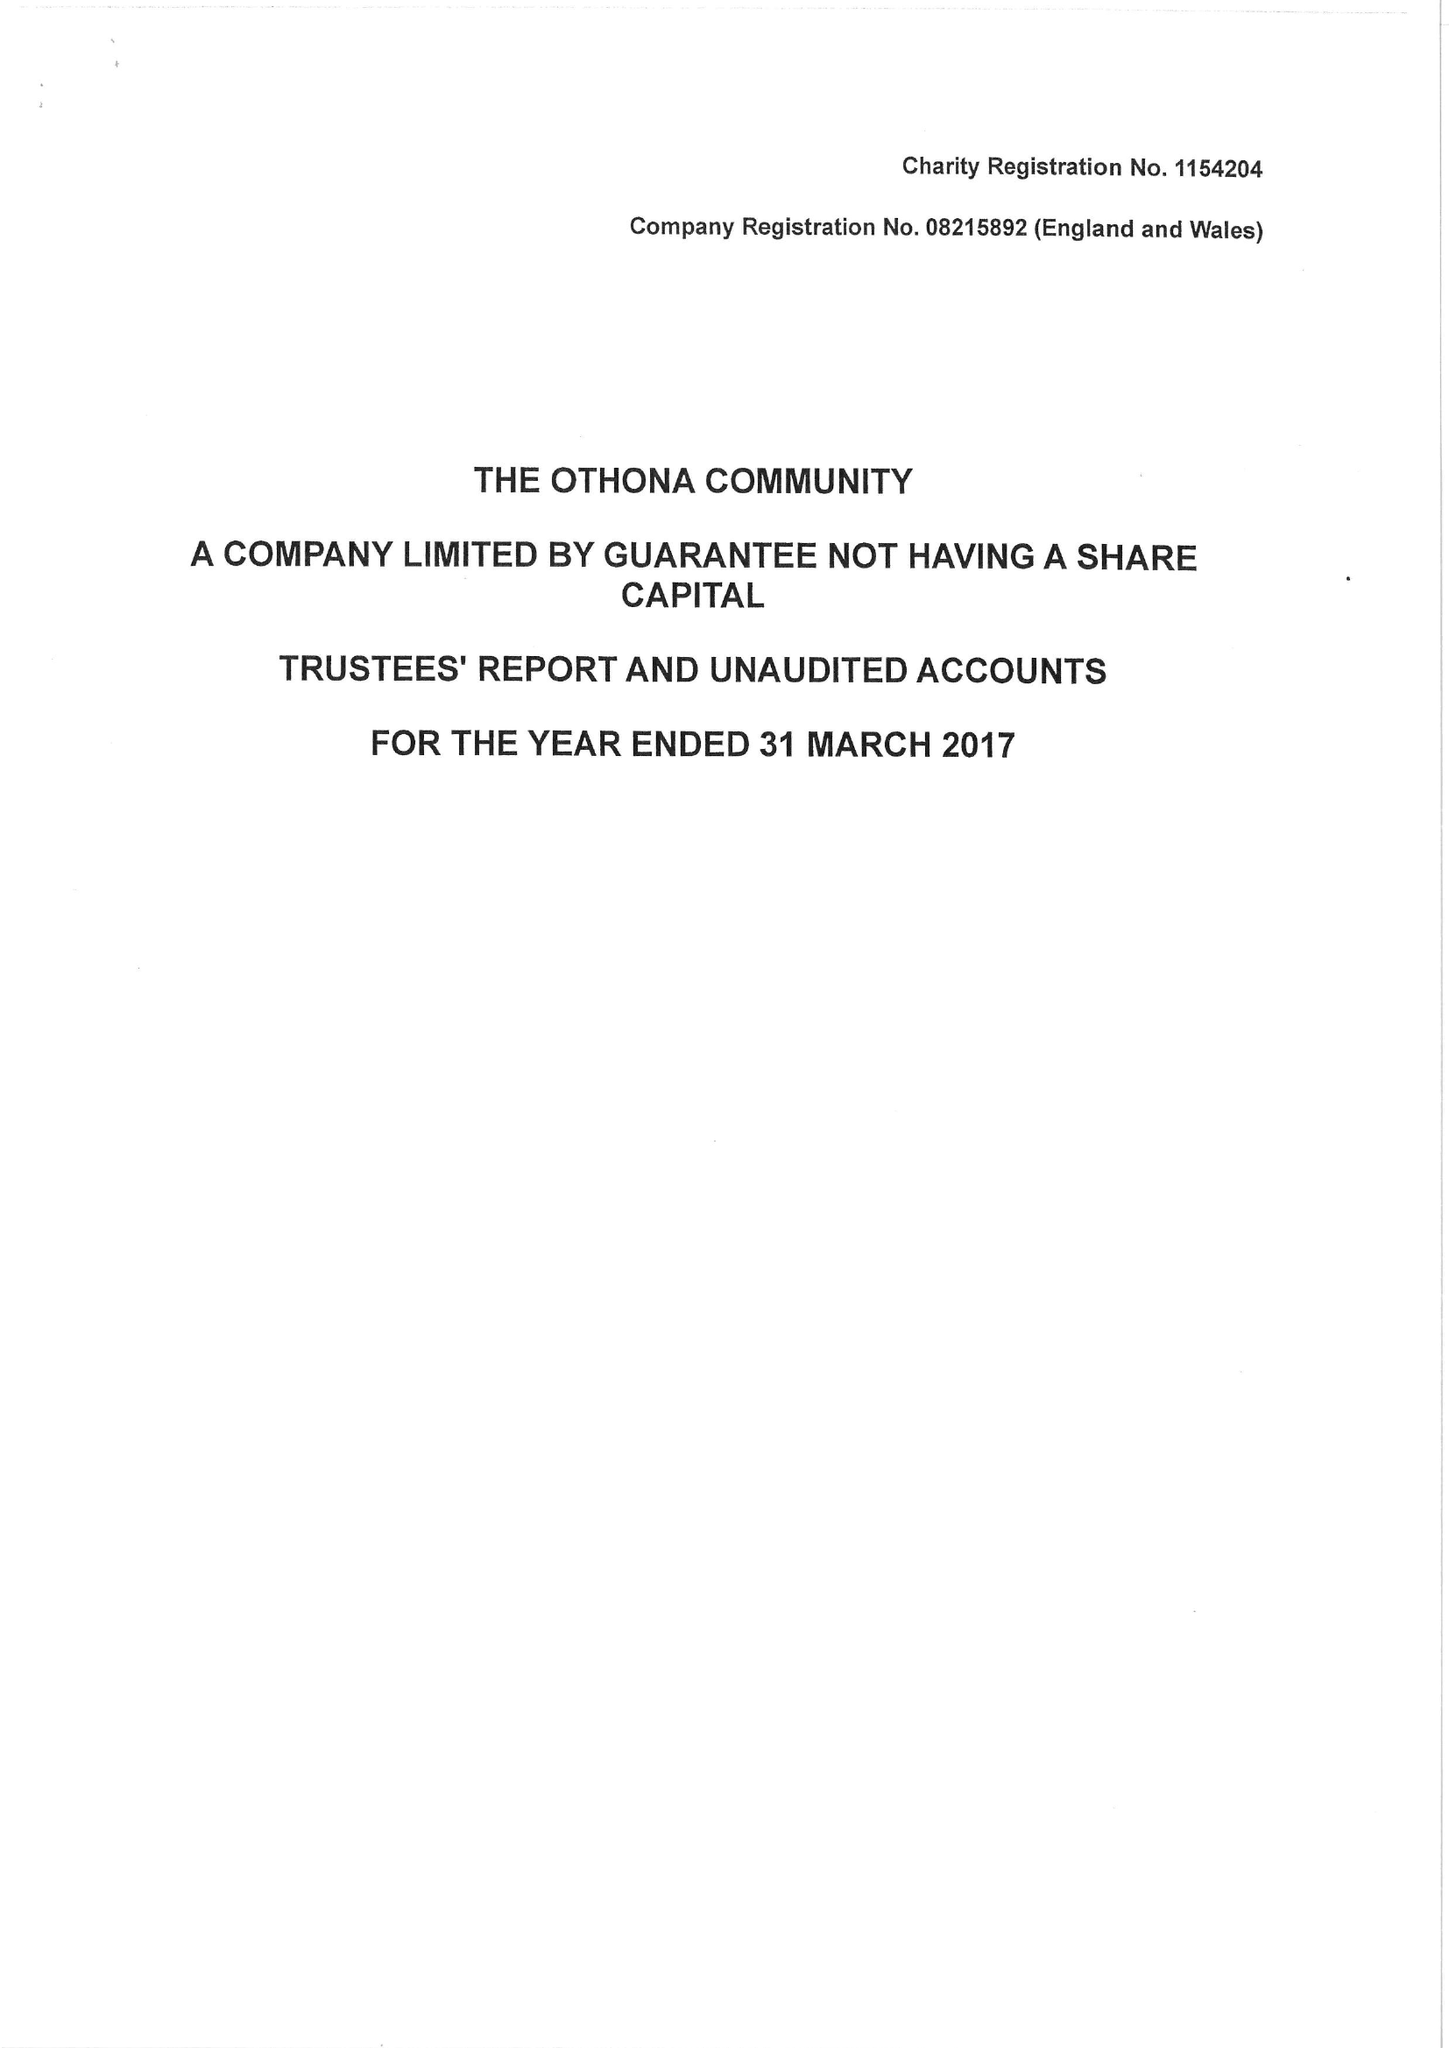What is the value for the report_date?
Answer the question using a single word or phrase. 2017-03-31 